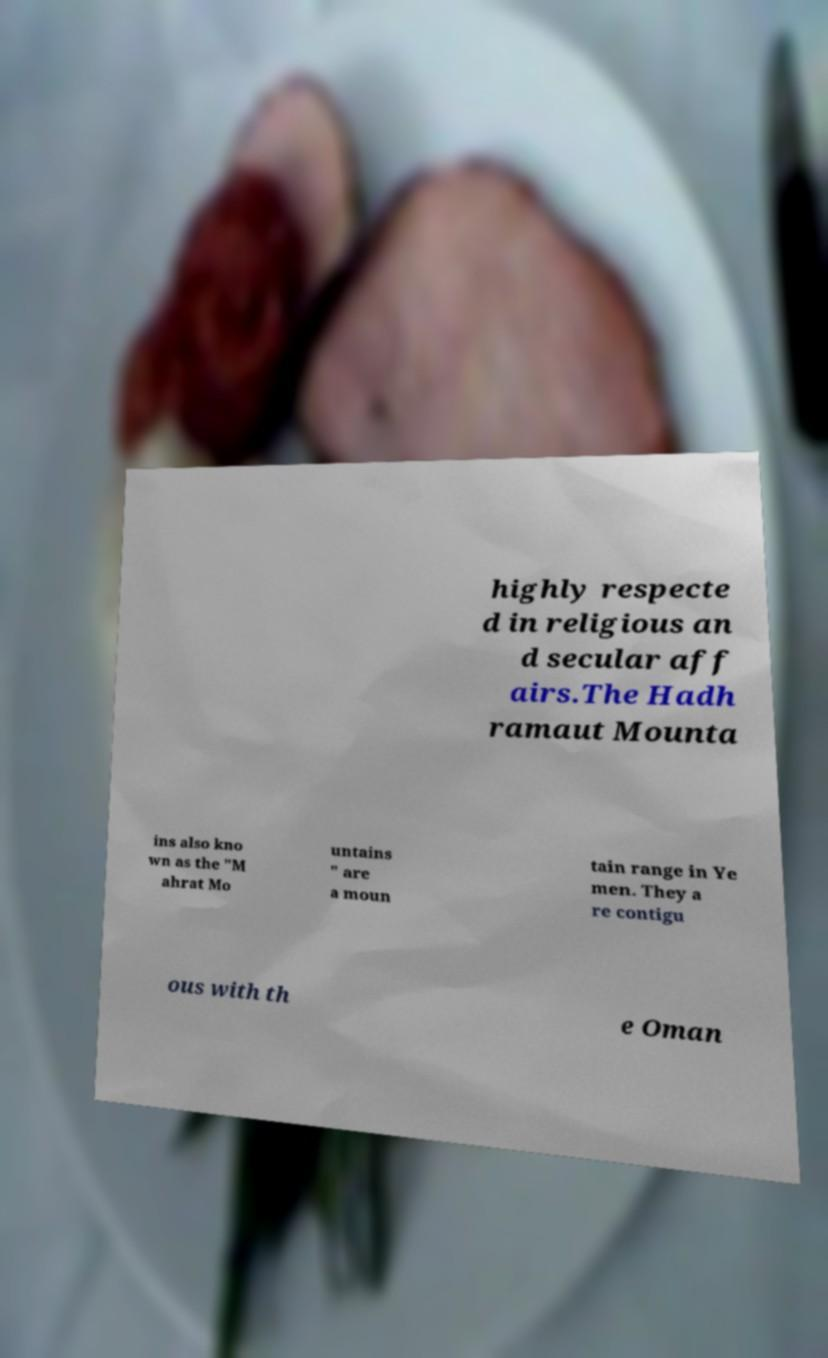Please identify and transcribe the text found in this image. highly respecte d in religious an d secular aff airs.The Hadh ramaut Mounta ins also kno wn as the "M ahrat Mo untains " are a moun tain range in Ye men. They a re contigu ous with th e Oman 